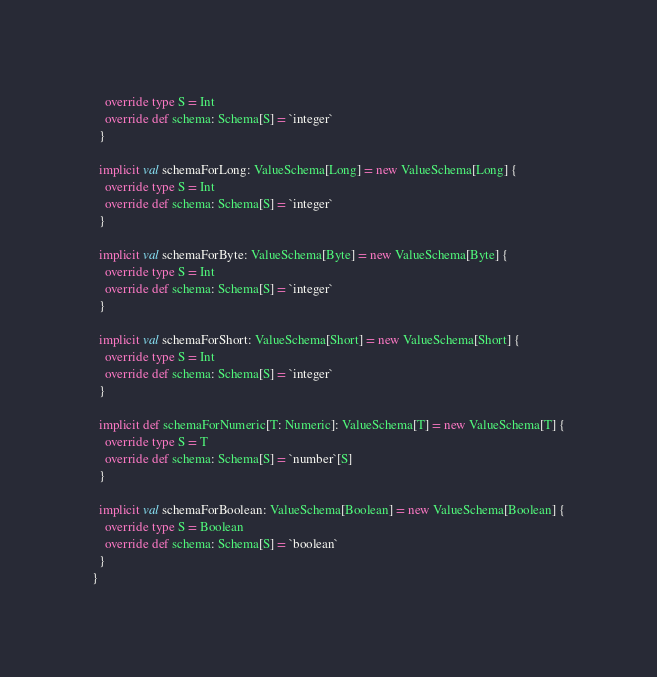Convert code to text. <code><loc_0><loc_0><loc_500><loc_500><_Scala_>    override type S = Int
    override def schema: Schema[S] = `integer`
  }

  implicit val schemaForLong: ValueSchema[Long] = new ValueSchema[Long] {
    override type S = Int
    override def schema: Schema[S] = `integer`
  }

  implicit val schemaForByte: ValueSchema[Byte] = new ValueSchema[Byte] {
    override type S = Int
    override def schema: Schema[S] = `integer`
  }

  implicit val schemaForShort: ValueSchema[Short] = new ValueSchema[Short] {
    override type S = Int
    override def schema: Schema[S] = `integer`
  }

  implicit def schemaForNumeric[T: Numeric]: ValueSchema[T] = new ValueSchema[T] {
    override type S = T
    override def schema: Schema[S] = `number`[S]
  }

  implicit val schemaForBoolean: ValueSchema[Boolean] = new ValueSchema[Boolean] {
    override type S = Boolean
    override def schema: Schema[S] = `boolean`
  }
}
</code> 